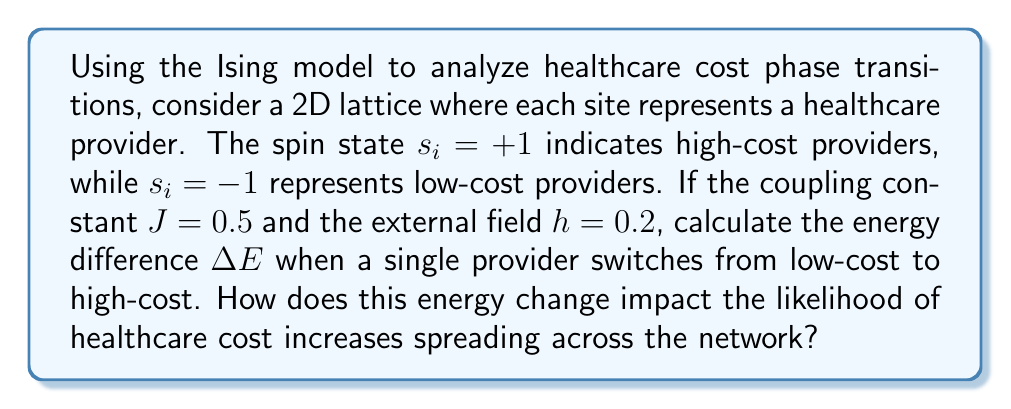Can you solve this math problem? To solve this problem, we'll use the Ising model energy equation and calculate the energy difference:

1) The Ising model energy equation is:
   $$E = -J\sum_{<i,j>} s_is_j - h\sum_i s_i$$

2) For a 2D lattice, each site has 4 nearest neighbors. Let's assume the switching provider has 2 high-cost and 2 low-cost neighbors.

3) Initial energy contribution of the switching provider:
   $$E_1 = -J((-1)(1) + (-1)(1) + (-1)(-1) + (-1)(-1)) - h(-1) = 0 + 0.2 = 0.2$$

4) Final energy contribution after switching:
   $$E_2 = -J((1)(1) + (1)(1) + (1)(-1) + (1)(-1)) - h(1) = -1 - 0.2 = -1.2$$

5) Calculate the energy difference:
   $$\Delta E = E_2 - E_1 = -1.2 - 0.2 = -1.4$$

6) The negative energy change indicates that the system favors the switch to high-cost, making it more likely for healthcare costs to increase and spread across the network.
Answer: $\Delta E = -1.4$; Negative energy change promotes cost increase spread. 